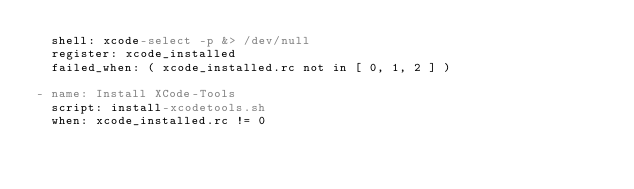Convert code to text. <code><loc_0><loc_0><loc_500><loc_500><_YAML_>  shell: xcode-select -p &> /dev/null
  register: xcode_installed
  failed_when: ( xcode_installed.rc not in [ 0, 1, 2 ] )

- name: Install XCode-Tools
  script: install-xcodetools.sh
  when: xcode_installed.rc != 0</code> 